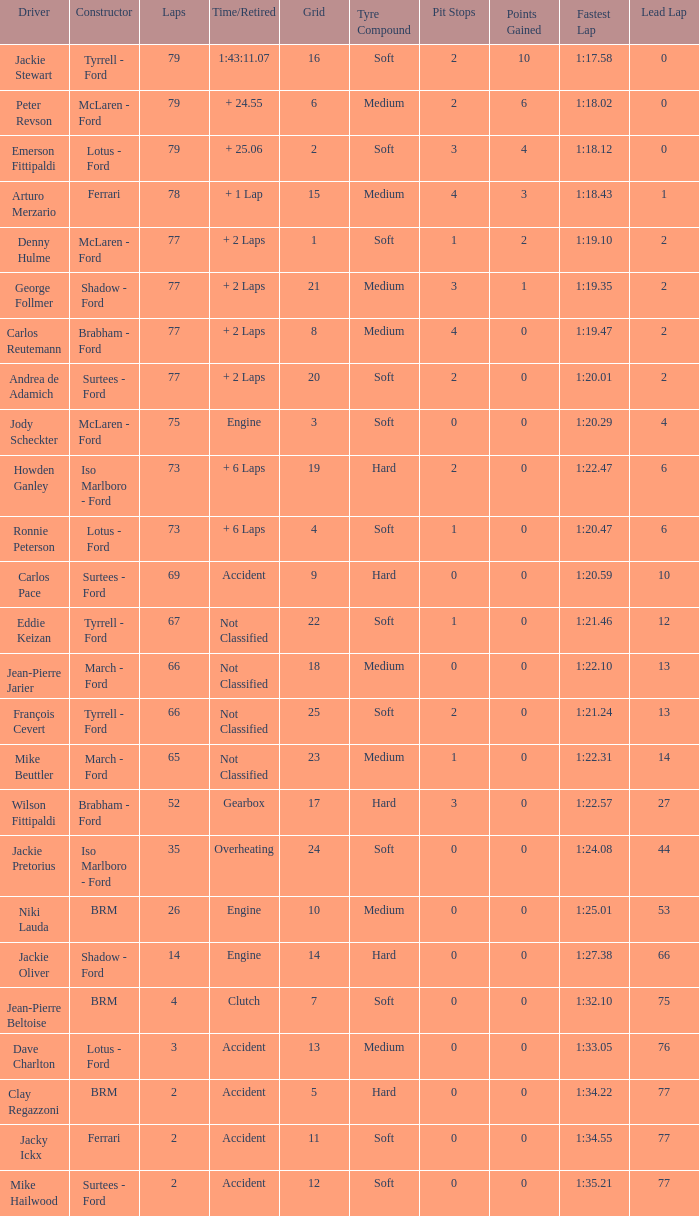What is the total grid with laps less than 2? None. 